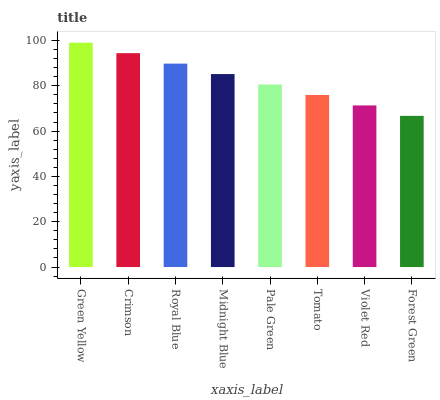Is Forest Green the minimum?
Answer yes or no. Yes. Is Green Yellow the maximum?
Answer yes or no. Yes. Is Crimson the minimum?
Answer yes or no. No. Is Crimson the maximum?
Answer yes or no. No. Is Green Yellow greater than Crimson?
Answer yes or no. Yes. Is Crimson less than Green Yellow?
Answer yes or no. Yes. Is Crimson greater than Green Yellow?
Answer yes or no. No. Is Green Yellow less than Crimson?
Answer yes or no. No. Is Midnight Blue the high median?
Answer yes or no. Yes. Is Pale Green the low median?
Answer yes or no. Yes. Is Royal Blue the high median?
Answer yes or no. No. Is Green Yellow the low median?
Answer yes or no. No. 